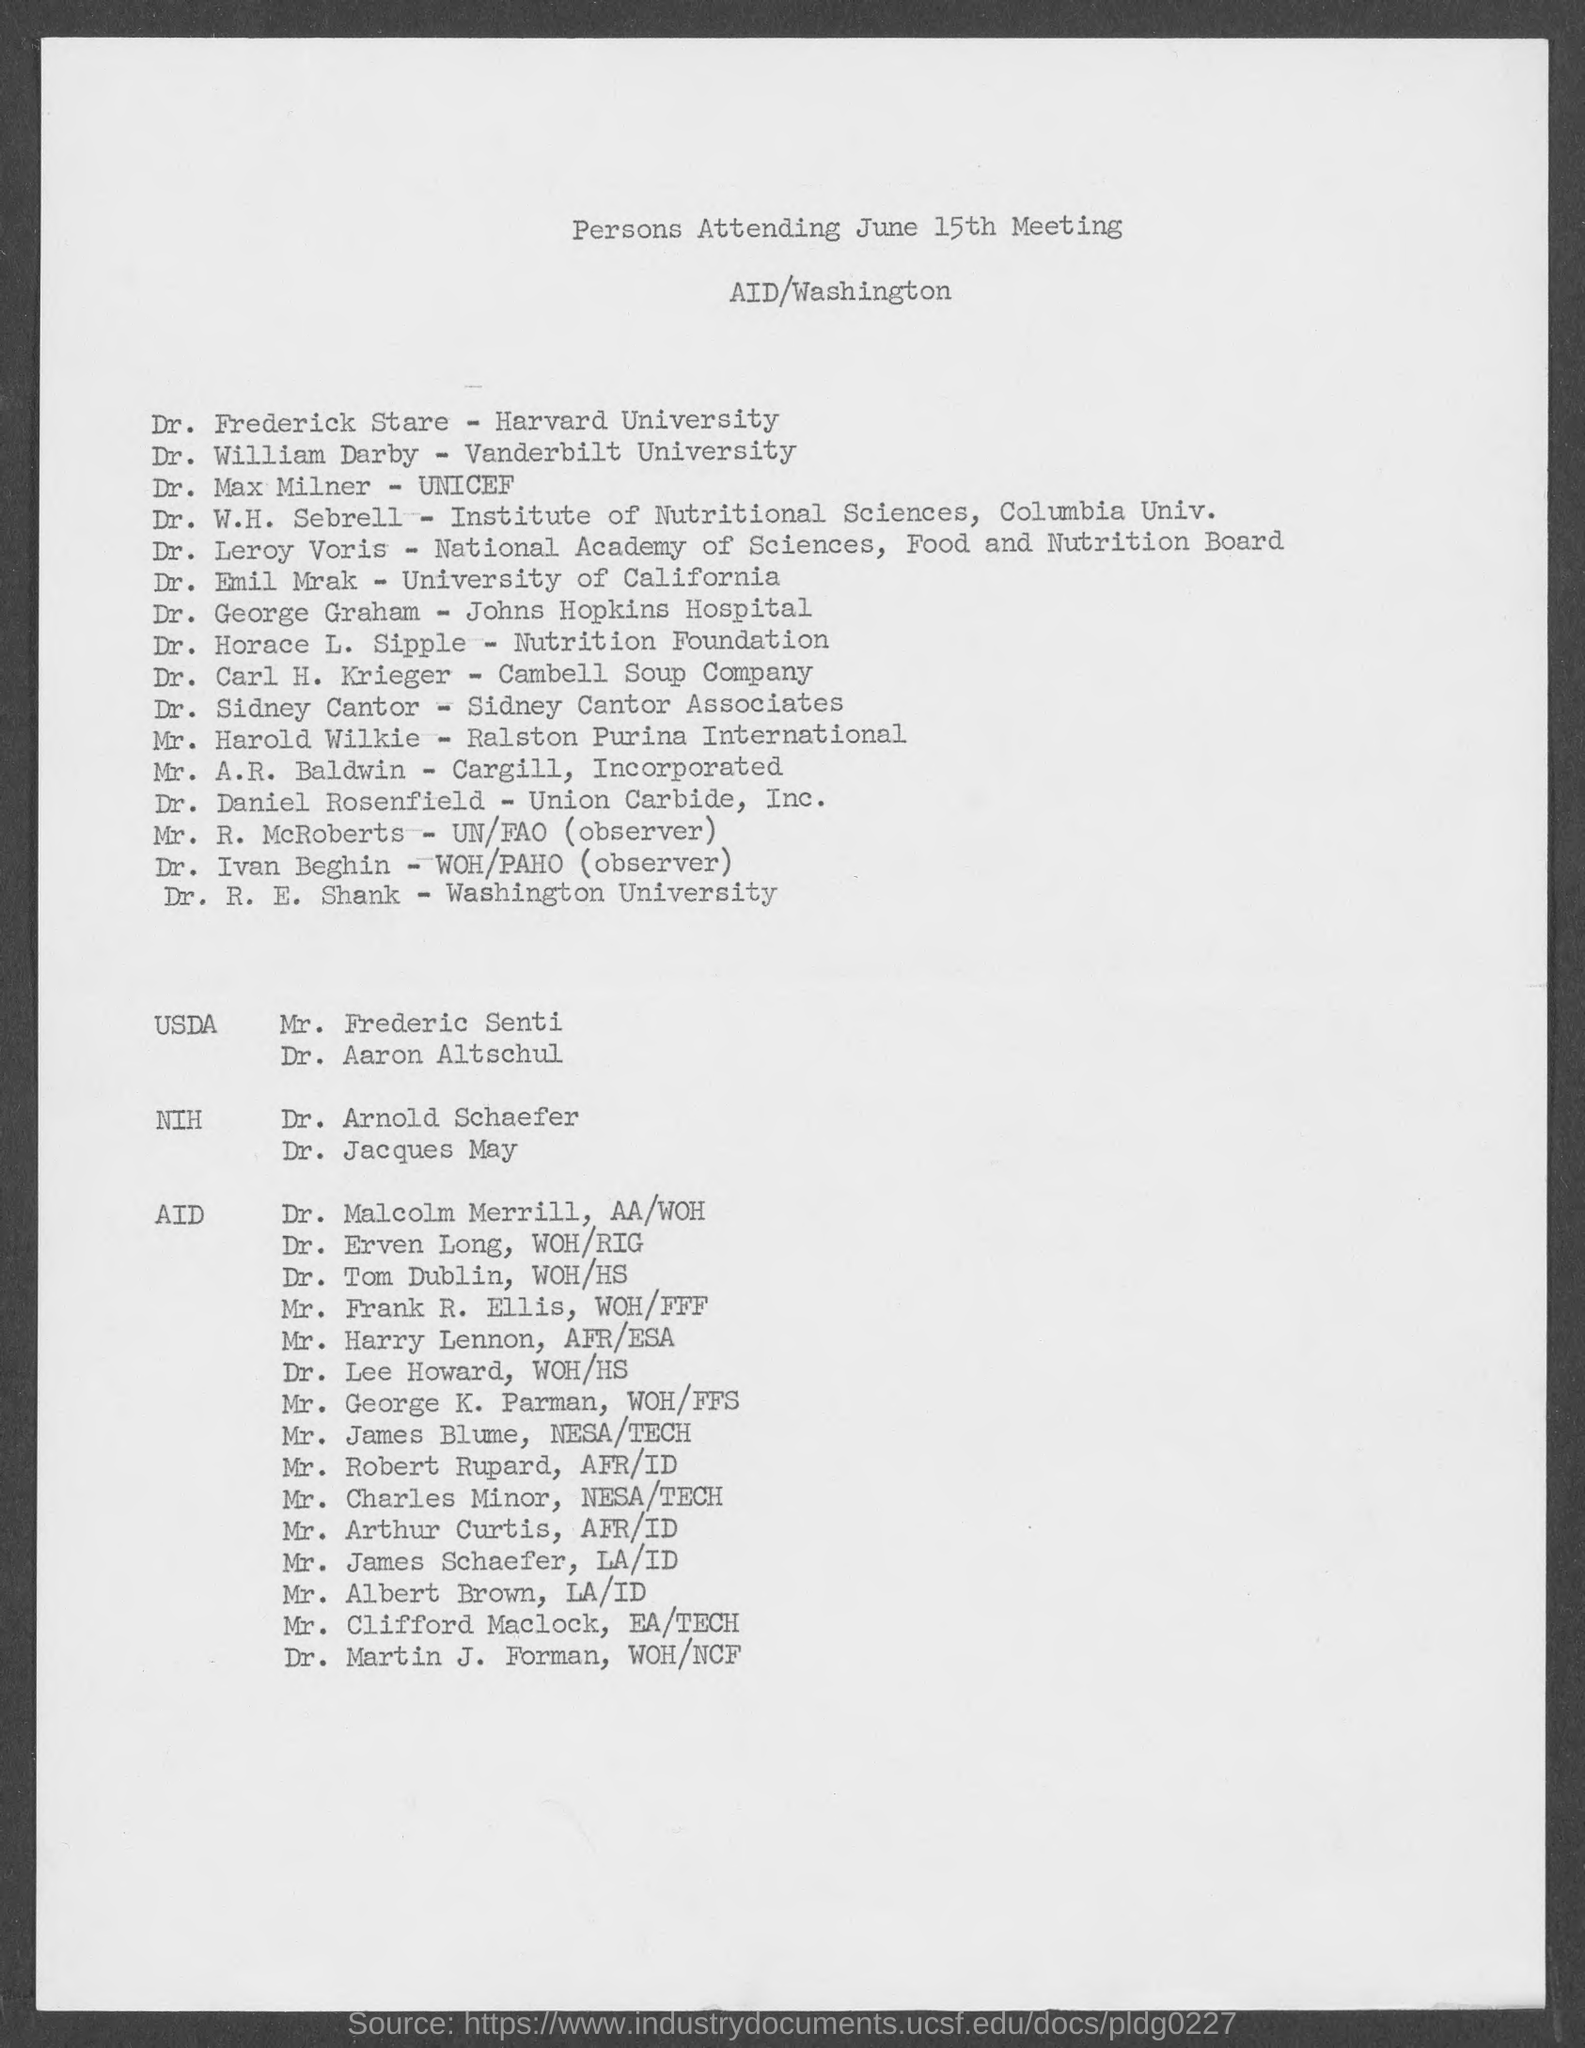Give some essential details in this illustration. The meeting is held in Washington. The document lists the persons who attended the June 15th meeting. UNICEF will be represented by Dr. Max Milner at the meeting. The meeting will be held on June 15th. Dr. Frederick Stare is a professor at Harvard University. 